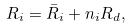<formula> <loc_0><loc_0><loc_500><loc_500>R _ { i } = \bar { R } _ { i } + n _ { i } R _ { d } ,</formula> 